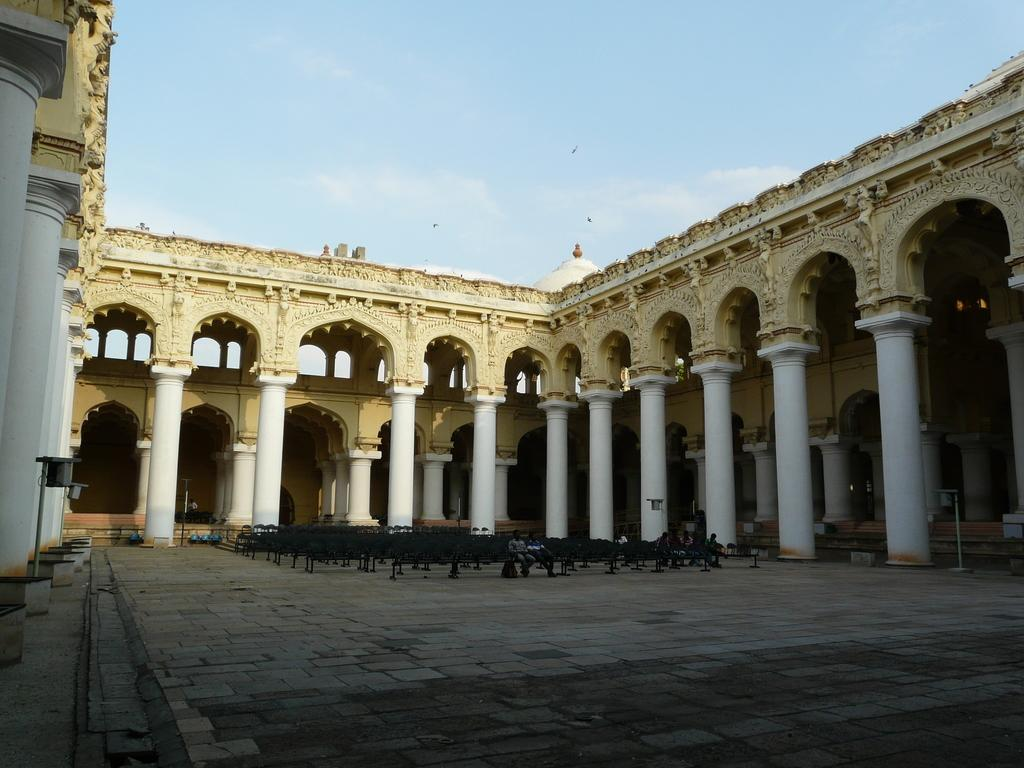What type of structure is visible in the image? There is a building in the image. What are the people in the image doing? The people in the image are seated on chairs. How would you describe the sky in the image? The sky is blue and cloudy in the image. How many steel spiders are crawling on the building in the image? There are no spiders, steel or otherwise, visible on the building in the image. 